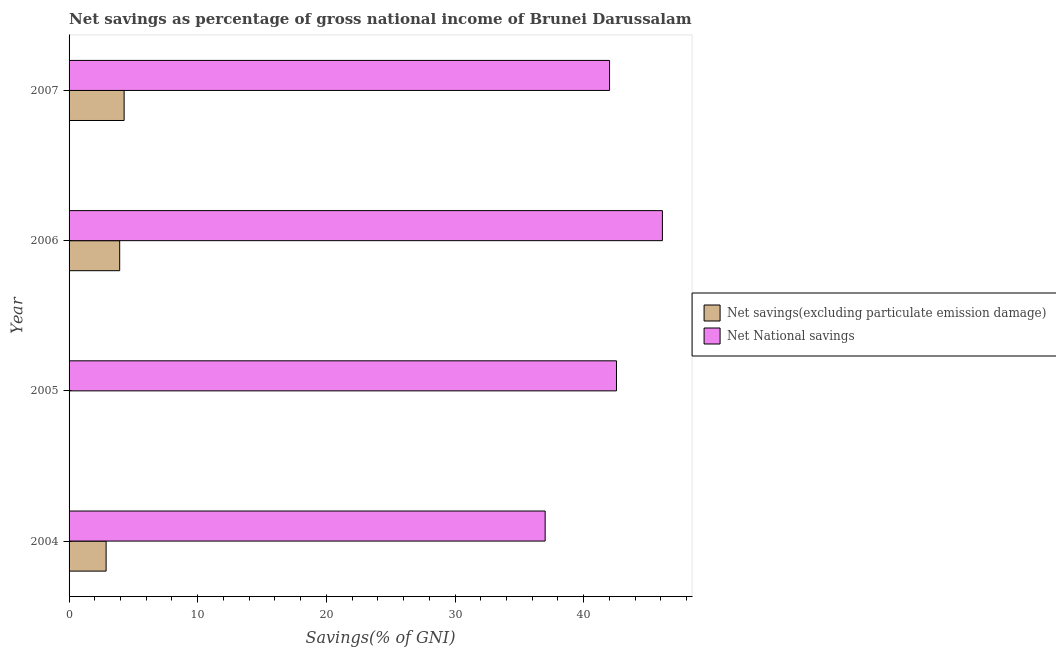Are the number of bars per tick equal to the number of legend labels?
Make the answer very short. No. Are the number of bars on each tick of the Y-axis equal?
Ensure brevity in your answer.  No. How many bars are there on the 2nd tick from the top?
Your answer should be very brief. 2. What is the label of the 4th group of bars from the top?
Your response must be concise. 2004. What is the net savings(excluding particulate emission damage) in 2004?
Your response must be concise. 2.88. Across all years, what is the maximum net national savings?
Ensure brevity in your answer.  46.12. Across all years, what is the minimum net savings(excluding particulate emission damage)?
Provide a succinct answer. 0. In which year was the net national savings maximum?
Your response must be concise. 2006. What is the total net national savings in the graph?
Make the answer very short. 167.7. What is the difference between the net national savings in 2006 and that in 2007?
Your response must be concise. 4.11. What is the difference between the net savings(excluding particulate emission damage) in 2005 and the net national savings in 2007?
Your answer should be compact. -42.02. What is the average net national savings per year?
Offer a very short reply. 41.93. In the year 2004, what is the difference between the net national savings and net savings(excluding particulate emission damage)?
Your answer should be very brief. 34.13. What is the difference between the highest and the second highest net national savings?
Provide a succinct answer. 3.57. What is the difference between the highest and the lowest net savings(excluding particulate emission damage)?
Make the answer very short. 4.28. Are the values on the major ticks of X-axis written in scientific E-notation?
Your answer should be very brief. No. Where does the legend appear in the graph?
Make the answer very short. Center right. What is the title of the graph?
Ensure brevity in your answer.  Net savings as percentage of gross national income of Brunei Darussalam. What is the label or title of the X-axis?
Ensure brevity in your answer.  Savings(% of GNI). What is the label or title of the Y-axis?
Give a very brief answer. Year. What is the Savings(% of GNI) of Net savings(excluding particulate emission damage) in 2004?
Offer a very short reply. 2.88. What is the Savings(% of GNI) of Net National savings in 2004?
Your answer should be very brief. 37.01. What is the Savings(% of GNI) of Net savings(excluding particulate emission damage) in 2005?
Make the answer very short. 0. What is the Savings(% of GNI) in Net National savings in 2005?
Provide a short and direct response. 42.55. What is the Savings(% of GNI) of Net savings(excluding particulate emission damage) in 2006?
Make the answer very short. 3.93. What is the Savings(% of GNI) in Net National savings in 2006?
Your response must be concise. 46.12. What is the Savings(% of GNI) in Net savings(excluding particulate emission damage) in 2007?
Provide a succinct answer. 4.28. What is the Savings(% of GNI) of Net National savings in 2007?
Provide a short and direct response. 42.02. Across all years, what is the maximum Savings(% of GNI) of Net savings(excluding particulate emission damage)?
Make the answer very short. 4.28. Across all years, what is the maximum Savings(% of GNI) of Net National savings?
Keep it short and to the point. 46.12. Across all years, what is the minimum Savings(% of GNI) of Net National savings?
Make the answer very short. 37.01. What is the total Savings(% of GNI) in Net savings(excluding particulate emission damage) in the graph?
Give a very brief answer. 11.09. What is the total Savings(% of GNI) in Net National savings in the graph?
Offer a very short reply. 167.7. What is the difference between the Savings(% of GNI) in Net National savings in 2004 and that in 2005?
Keep it short and to the point. -5.54. What is the difference between the Savings(% of GNI) in Net savings(excluding particulate emission damage) in 2004 and that in 2006?
Make the answer very short. -1.06. What is the difference between the Savings(% of GNI) of Net National savings in 2004 and that in 2006?
Your response must be concise. -9.11. What is the difference between the Savings(% of GNI) in Net savings(excluding particulate emission damage) in 2004 and that in 2007?
Your response must be concise. -1.4. What is the difference between the Savings(% of GNI) of Net National savings in 2004 and that in 2007?
Ensure brevity in your answer.  -5.01. What is the difference between the Savings(% of GNI) in Net National savings in 2005 and that in 2006?
Keep it short and to the point. -3.57. What is the difference between the Savings(% of GNI) in Net National savings in 2005 and that in 2007?
Your answer should be very brief. 0.54. What is the difference between the Savings(% of GNI) in Net savings(excluding particulate emission damage) in 2006 and that in 2007?
Your response must be concise. -0.34. What is the difference between the Savings(% of GNI) of Net National savings in 2006 and that in 2007?
Your answer should be very brief. 4.11. What is the difference between the Savings(% of GNI) in Net savings(excluding particulate emission damage) in 2004 and the Savings(% of GNI) in Net National savings in 2005?
Provide a succinct answer. -39.67. What is the difference between the Savings(% of GNI) in Net savings(excluding particulate emission damage) in 2004 and the Savings(% of GNI) in Net National savings in 2006?
Offer a very short reply. -43.24. What is the difference between the Savings(% of GNI) of Net savings(excluding particulate emission damage) in 2004 and the Savings(% of GNI) of Net National savings in 2007?
Make the answer very short. -39.14. What is the difference between the Savings(% of GNI) of Net savings(excluding particulate emission damage) in 2006 and the Savings(% of GNI) of Net National savings in 2007?
Provide a succinct answer. -38.08. What is the average Savings(% of GNI) of Net savings(excluding particulate emission damage) per year?
Your answer should be compact. 2.77. What is the average Savings(% of GNI) in Net National savings per year?
Make the answer very short. 41.93. In the year 2004, what is the difference between the Savings(% of GNI) of Net savings(excluding particulate emission damage) and Savings(% of GNI) of Net National savings?
Your answer should be compact. -34.13. In the year 2006, what is the difference between the Savings(% of GNI) of Net savings(excluding particulate emission damage) and Savings(% of GNI) of Net National savings?
Provide a succinct answer. -42.19. In the year 2007, what is the difference between the Savings(% of GNI) of Net savings(excluding particulate emission damage) and Savings(% of GNI) of Net National savings?
Offer a terse response. -37.74. What is the ratio of the Savings(% of GNI) of Net National savings in 2004 to that in 2005?
Offer a very short reply. 0.87. What is the ratio of the Savings(% of GNI) of Net savings(excluding particulate emission damage) in 2004 to that in 2006?
Offer a terse response. 0.73. What is the ratio of the Savings(% of GNI) in Net National savings in 2004 to that in 2006?
Your response must be concise. 0.8. What is the ratio of the Savings(% of GNI) in Net savings(excluding particulate emission damage) in 2004 to that in 2007?
Make the answer very short. 0.67. What is the ratio of the Savings(% of GNI) of Net National savings in 2004 to that in 2007?
Give a very brief answer. 0.88. What is the ratio of the Savings(% of GNI) in Net National savings in 2005 to that in 2006?
Your answer should be very brief. 0.92. What is the ratio of the Savings(% of GNI) in Net National savings in 2005 to that in 2007?
Make the answer very short. 1.01. What is the ratio of the Savings(% of GNI) in Net savings(excluding particulate emission damage) in 2006 to that in 2007?
Provide a short and direct response. 0.92. What is the ratio of the Savings(% of GNI) of Net National savings in 2006 to that in 2007?
Your response must be concise. 1.1. What is the difference between the highest and the second highest Savings(% of GNI) of Net savings(excluding particulate emission damage)?
Your answer should be compact. 0.34. What is the difference between the highest and the second highest Savings(% of GNI) of Net National savings?
Your response must be concise. 3.57. What is the difference between the highest and the lowest Savings(% of GNI) in Net savings(excluding particulate emission damage)?
Your answer should be very brief. 4.28. What is the difference between the highest and the lowest Savings(% of GNI) of Net National savings?
Offer a very short reply. 9.11. 